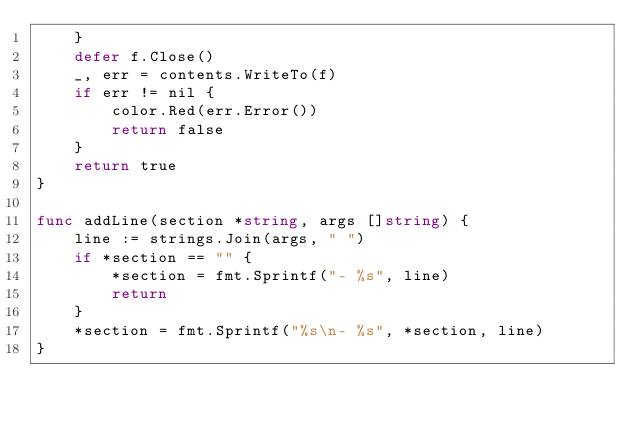<code> <loc_0><loc_0><loc_500><loc_500><_Go_>	}
	defer f.Close()
	_, err = contents.WriteTo(f)
	if err != nil {
		color.Red(err.Error())
		return false
	}
	return true
}

func addLine(section *string, args []string) {
	line := strings.Join(args, " ")
	if *section == "" {
		*section = fmt.Sprintf("- %s", line)
		return
	}
	*section = fmt.Sprintf("%s\n- %s", *section, line)
}
</code> 